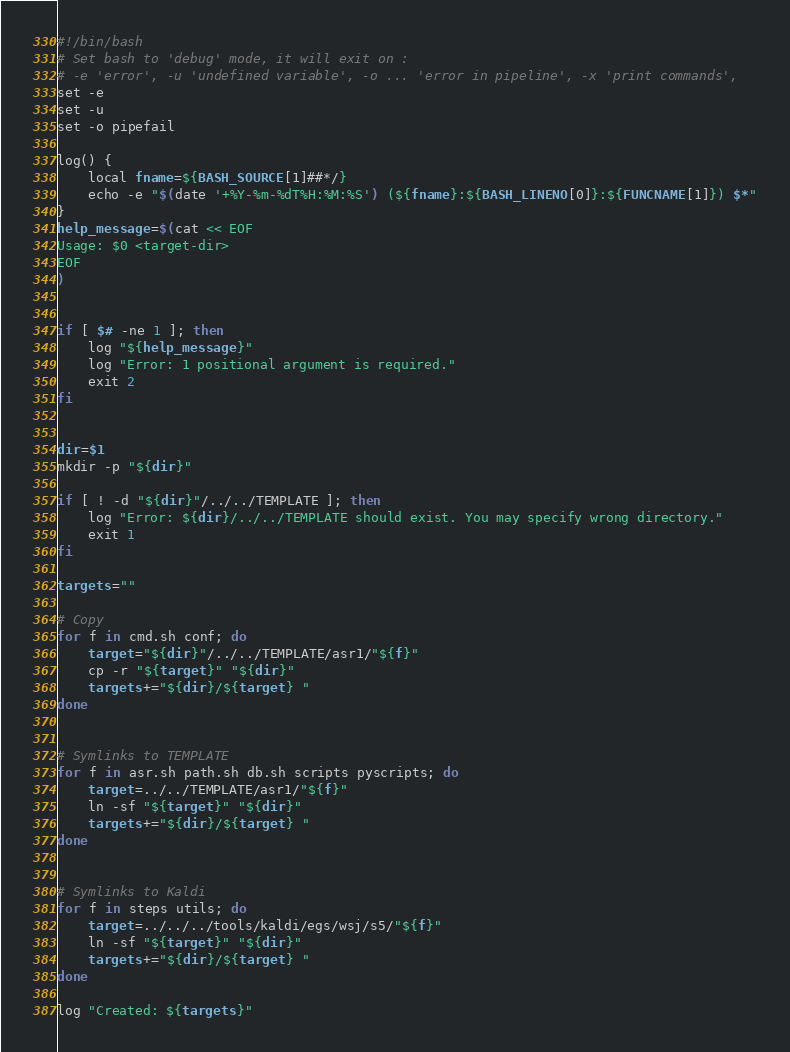<code> <loc_0><loc_0><loc_500><loc_500><_Bash_>#!/bin/bash
# Set bash to 'debug' mode, it will exit on :
# -e 'error', -u 'undefined variable', -o ... 'error in pipeline', -x 'print commands',
set -e
set -u
set -o pipefail

log() {
    local fname=${BASH_SOURCE[1]##*/}
    echo -e "$(date '+%Y-%m-%dT%H:%M:%S') (${fname}:${BASH_LINENO[0]}:${FUNCNAME[1]}) $*"
}
help_message=$(cat << EOF
Usage: $0 <target-dir>
EOF
)


if [ $# -ne 1 ]; then
    log "${help_message}"
    log "Error: 1 positional argument is required."
    exit 2
fi


dir=$1
mkdir -p "${dir}"

if [ ! -d "${dir}"/../../TEMPLATE ]; then
    log "Error: ${dir}/../../TEMPLATE should exist. You may specify wrong directory."
    exit 1
fi

targets=""

# Copy
for f in cmd.sh conf; do
    target="${dir}"/../../TEMPLATE/asr1/"${f}"
    cp -r "${target}" "${dir}"
    targets+="${dir}/${target} "
done


# Symlinks to TEMPLATE
for f in asr.sh path.sh db.sh scripts pyscripts; do
    target=../../TEMPLATE/asr1/"${f}"
    ln -sf "${target}" "${dir}"
    targets+="${dir}/${target} "
done


# Symlinks to Kaldi
for f in steps utils; do
    target=../../../tools/kaldi/egs/wsj/s5/"${f}"
    ln -sf "${target}" "${dir}"
    targets+="${dir}/${target} "
done

log "Created: ${targets}"
</code> 